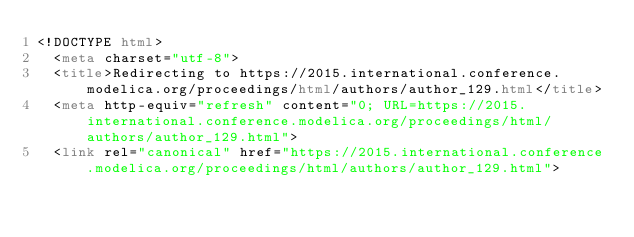Convert code to text. <code><loc_0><loc_0><loc_500><loc_500><_HTML_><!DOCTYPE html>
  <meta charset="utf-8">
  <title>Redirecting to https://2015.international.conference.modelica.org/proceedings/html/authors/author_129.html</title>
  <meta http-equiv="refresh" content="0; URL=https://2015.international.conference.modelica.org/proceedings/html/authors/author_129.html">
  <link rel="canonical" href="https://2015.international.conference.modelica.org/proceedings/html/authors/author_129.html">
  </code> 